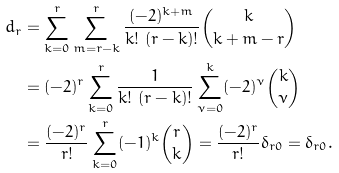<formula> <loc_0><loc_0><loc_500><loc_500>d _ { r } & = \sum _ { k = 0 } ^ { r } \sum _ { m = r - k } ^ { r } \frac { ( - 2 ) ^ { k + m } } { k ! \ ( r - k ) ! } \binom { k } { k + m - r } \\ & = ( - 2 ) ^ { r } \sum _ { k = 0 } ^ { r } \frac { 1 } { k ! \ ( r - k ) ! } \sum _ { \nu = 0 } ^ { k } ( - 2 ) ^ { \nu } \binom { k } { \nu } \\ & = \frac { ( - 2 ) ^ { r } } { r ! } \sum _ { k = 0 } ^ { r } ( - 1 ) ^ { k } \binom { r } { k } = \frac { ( - 2 ) ^ { r } } { r ! } \delta _ { r 0 } = \delta _ { r 0 } .</formula> 